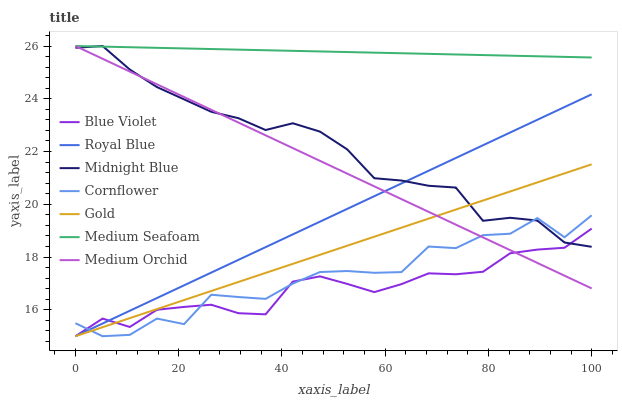Does Blue Violet have the minimum area under the curve?
Answer yes or no. Yes. Does Medium Seafoam have the maximum area under the curve?
Answer yes or no. Yes. Does Midnight Blue have the minimum area under the curve?
Answer yes or no. No. Does Midnight Blue have the maximum area under the curve?
Answer yes or no. No. Is Medium Seafoam the smoothest?
Answer yes or no. Yes. Is Cornflower the roughest?
Answer yes or no. Yes. Is Midnight Blue the smoothest?
Answer yes or no. No. Is Midnight Blue the roughest?
Answer yes or no. No. Does Midnight Blue have the lowest value?
Answer yes or no. No. Does Medium Seafoam have the highest value?
Answer yes or no. Yes. Does Gold have the highest value?
Answer yes or no. No. Is Royal Blue less than Medium Seafoam?
Answer yes or no. Yes. Is Medium Seafoam greater than Cornflower?
Answer yes or no. Yes. Does Midnight Blue intersect Gold?
Answer yes or no. Yes. Is Midnight Blue less than Gold?
Answer yes or no. No. Is Midnight Blue greater than Gold?
Answer yes or no. No. Does Royal Blue intersect Medium Seafoam?
Answer yes or no. No. 